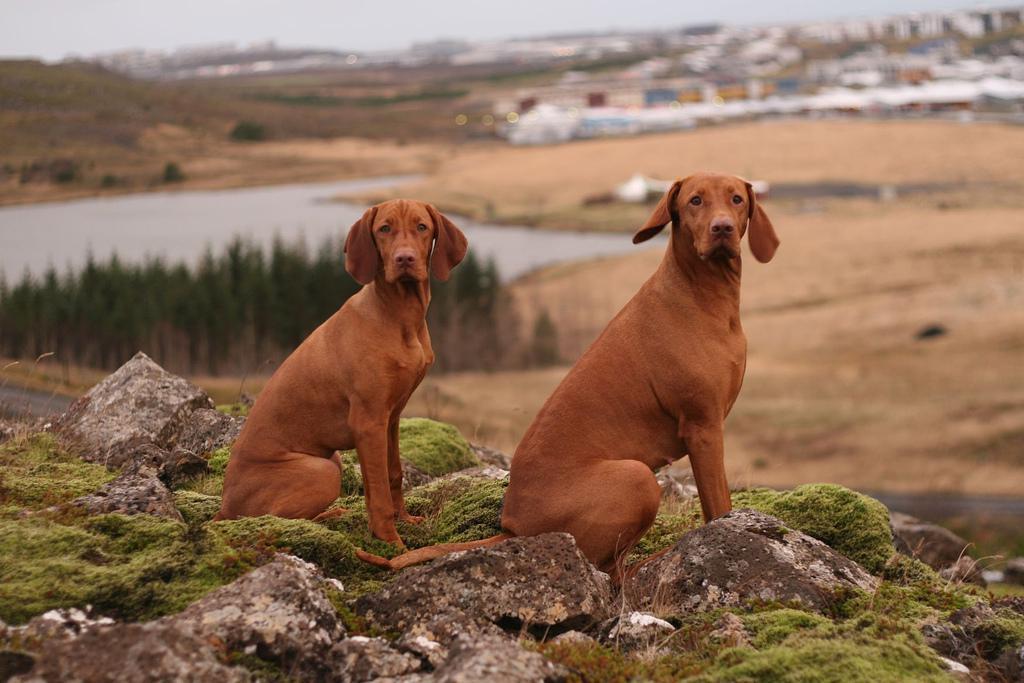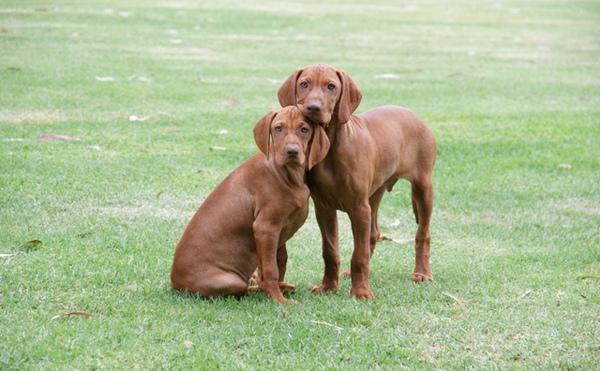The first image is the image on the left, the second image is the image on the right. Assess this claim about the two images: "There are at least four dogs in total.". Correct or not? Answer yes or no. Yes. The first image is the image on the left, the second image is the image on the right. Given the left and right images, does the statement "In the right image, there's a single Vizsla facing the right." hold true? Answer yes or no. No. 